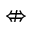<formula> <loc_0><loc_0><loc_500><loc_500>\ n L e f t r i g h t a r r o w</formula> 